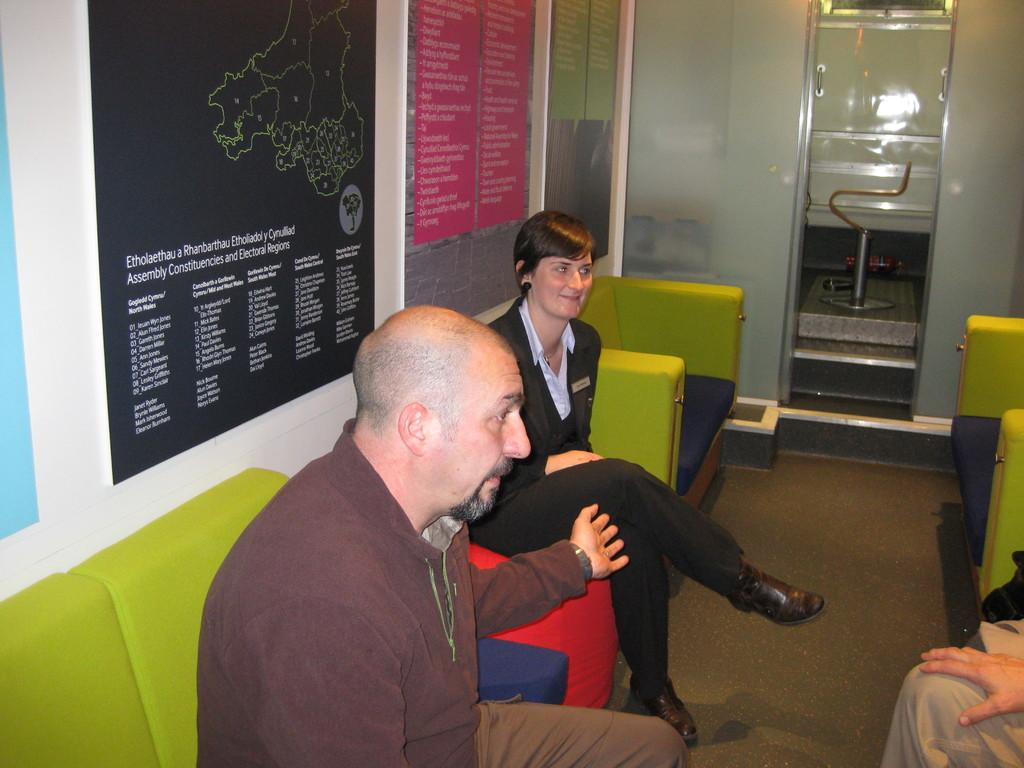Provide a one-sentence caption for the provided image. Three people sitting on couches discussing between themselves under a wall map of Etholaethau a Rhanbarthau Etholiaddol Cyrbullliad. 